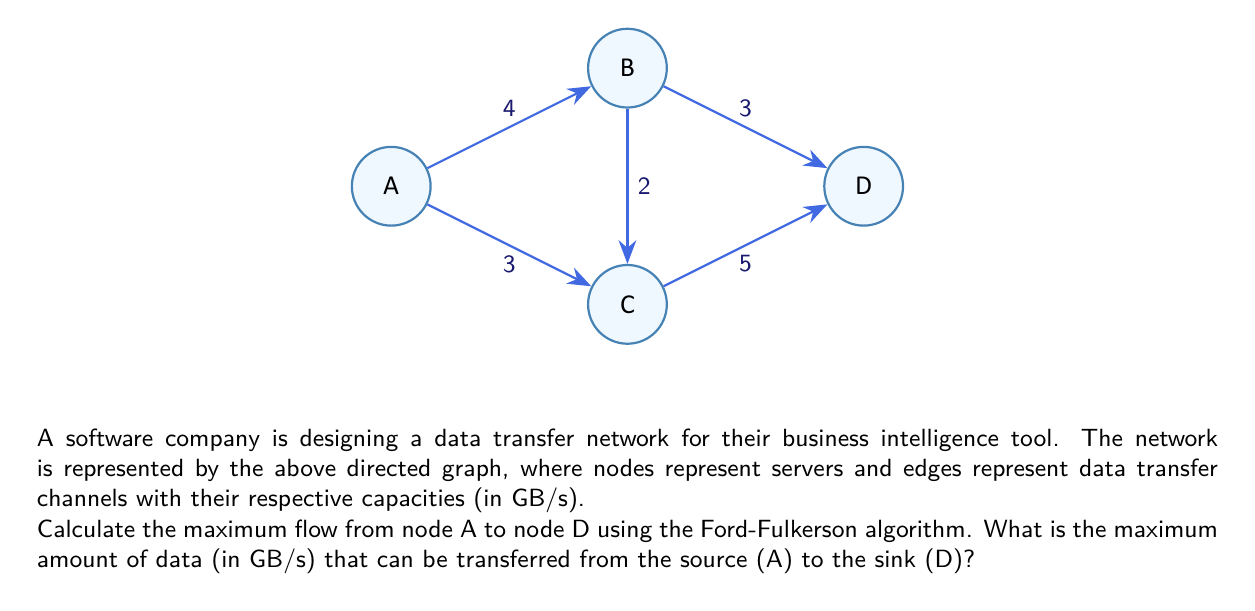Can you answer this question? To solve this problem, we'll use the Ford-Fulkerson algorithm to find the maximum flow from A to D. Here's a step-by-step explanation:

1. Initialize the flow to 0 for all edges.

2. Find an augmenting path from A to D:
   Path 1: A -> B -> D (min capacity: 3 GB/s)
   Increase flow by 3 GB/s along this path.

3. Update residual graph:
   A -> B: 4 - 3 = 1 GB/s
   B -> D: 3 - 3 = 0 GB/s
   Add reverse edges: B -> A: 3 GB/s, D -> B: 3 GB/s

4. Find another augmenting path:
   Path 2: A -> C -> D (min capacity: 3 GB/s)
   Increase flow by 3 GB/s along this path.

5. Update residual graph:
   A -> C: 3 - 3 = 0 GB/s
   C -> D: 5 - 3 = 2 GB/s
   Add reverse edges: C -> A: 3 GB/s, D -> C: 3 GB/s

6. Find another augmenting path:
   Path 3: A -> B -> C -> D (min capacity: 1 GB/s)
   Increase flow by 1 GB/s along this path.

7. Update residual graph:
   A -> B: 1 - 1 = 0 GB/s
   B -> C: 2 - 1 = 1 GB/s
   C -> D: 2 - 1 = 1 GB/s
   Add reverse edges: B -> A: 4 GB/s, C -> B: 1 GB/s, D -> C: 4 GB/s

8. No more augmenting paths exist.

9. Calculate total flow:
   Flow through A -> B -> D: 3 GB/s
   Flow through A -> C -> D: 3 GB/s
   Flow through A -> B -> C -> D: 1 GB/s

10. Sum up the flows: 3 + 3 + 1 = 7 GB/s

Therefore, the maximum flow from A to D is 7 GB/s.
Answer: 7 GB/s 